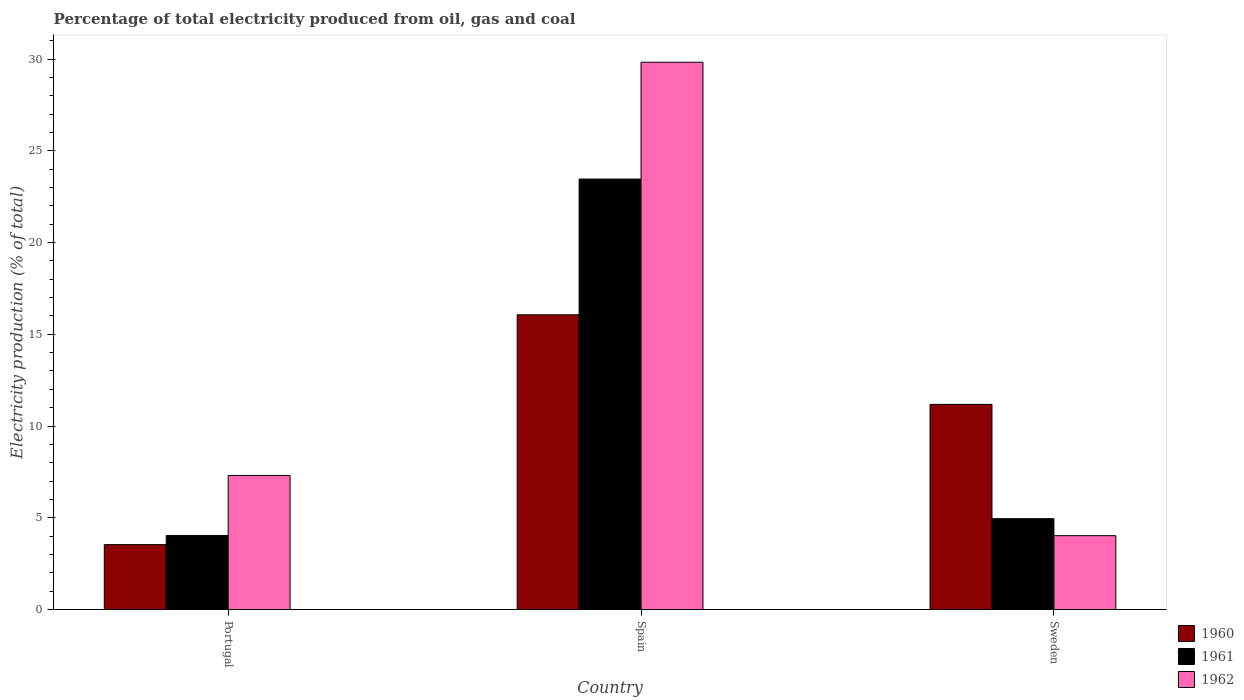How many groups of bars are there?
Make the answer very short. 3. Are the number of bars per tick equal to the number of legend labels?
Your answer should be very brief. Yes. How many bars are there on the 1st tick from the right?
Provide a succinct answer. 3. What is the label of the 1st group of bars from the left?
Give a very brief answer. Portugal. In how many cases, is the number of bars for a given country not equal to the number of legend labels?
Your answer should be compact. 0. What is the electricity production in in 1960 in Spain?
Keep it short and to the point. 16.06. Across all countries, what is the maximum electricity production in in 1962?
Give a very brief answer. 29.83. Across all countries, what is the minimum electricity production in in 1960?
Offer a very short reply. 3.54. What is the total electricity production in in 1961 in the graph?
Make the answer very short. 32.45. What is the difference between the electricity production in in 1960 in Spain and that in Sweden?
Keep it short and to the point. 4.88. What is the difference between the electricity production in in 1962 in Portugal and the electricity production in in 1961 in Sweden?
Your answer should be compact. 2.36. What is the average electricity production in in 1960 per country?
Make the answer very short. 10.26. What is the difference between the electricity production in of/in 1960 and electricity production in of/in 1961 in Spain?
Keep it short and to the point. -7.4. What is the ratio of the electricity production in in 1962 in Portugal to that in Sweden?
Your response must be concise. 1.82. Is the electricity production in in 1962 in Portugal less than that in Spain?
Give a very brief answer. Yes. What is the difference between the highest and the second highest electricity production in in 1960?
Your answer should be compact. 4.88. What is the difference between the highest and the lowest electricity production in in 1961?
Provide a short and direct response. 19.42. Is the sum of the electricity production in in 1961 in Portugal and Sweden greater than the maximum electricity production in in 1962 across all countries?
Give a very brief answer. No. Is it the case that in every country, the sum of the electricity production in in 1961 and electricity production in in 1962 is greater than the electricity production in in 1960?
Offer a terse response. No. Are all the bars in the graph horizontal?
Your response must be concise. No. Does the graph contain any zero values?
Ensure brevity in your answer.  No. Does the graph contain grids?
Make the answer very short. No. Where does the legend appear in the graph?
Ensure brevity in your answer.  Bottom right. How are the legend labels stacked?
Your response must be concise. Vertical. What is the title of the graph?
Your response must be concise. Percentage of total electricity produced from oil, gas and coal. What is the label or title of the Y-axis?
Your answer should be compact. Electricity production (% of total). What is the Electricity production (% of total) of 1960 in Portugal?
Offer a terse response. 3.54. What is the Electricity production (% of total) of 1961 in Portugal?
Your answer should be very brief. 4.04. What is the Electricity production (% of total) in 1962 in Portugal?
Your answer should be very brief. 7.31. What is the Electricity production (% of total) in 1960 in Spain?
Make the answer very short. 16.06. What is the Electricity production (% of total) of 1961 in Spain?
Your response must be concise. 23.46. What is the Electricity production (% of total) in 1962 in Spain?
Give a very brief answer. 29.83. What is the Electricity production (% of total) of 1960 in Sweden?
Keep it short and to the point. 11.18. What is the Electricity production (% of total) of 1961 in Sweden?
Provide a short and direct response. 4.95. What is the Electricity production (% of total) in 1962 in Sweden?
Make the answer very short. 4.02. Across all countries, what is the maximum Electricity production (% of total) in 1960?
Make the answer very short. 16.06. Across all countries, what is the maximum Electricity production (% of total) in 1961?
Ensure brevity in your answer.  23.46. Across all countries, what is the maximum Electricity production (% of total) of 1962?
Your response must be concise. 29.83. Across all countries, what is the minimum Electricity production (% of total) of 1960?
Provide a short and direct response. 3.54. Across all countries, what is the minimum Electricity production (% of total) in 1961?
Your response must be concise. 4.04. Across all countries, what is the minimum Electricity production (% of total) in 1962?
Your response must be concise. 4.02. What is the total Electricity production (% of total) of 1960 in the graph?
Keep it short and to the point. 30.78. What is the total Electricity production (% of total) of 1961 in the graph?
Ensure brevity in your answer.  32.45. What is the total Electricity production (% of total) of 1962 in the graph?
Give a very brief answer. 41.16. What is the difference between the Electricity production (% of total) of 1960 in Portugal and that in Spain?
Ensure brevity in your answer.  -12.53. What is the difference between the Electricity production (% of total) of 1961 in Portugal and that in Spain?
Provide a succinct answer. -19.42. What is the difference between the Electricity production (% of total) in 1962 in Portugal and that in Spain?
Your answer should be very brief. -22.52. What is the difference between the Electricity production (% of total) in 1960 in Portugal and that in Sweden?
Your answer should be very brief. -7.64. What is the difference between the Electricity production (% of total) in 1961 in Portugal and that in Sweden?
Provide a short and direct response. -0.92. What is the difference between the Electricity production (% of total) in 1962 in Portugal and that in Sweden?
Ensure brevity in your answer.  3.28. What is the difference between the Electricity production (% of total) in 1960 in Spain and that in Sweden?
Offer a very short reply. 4.88. What is the difference between the Electricity production (% of total) of 1961 in Spain and that in Sweden?
Your answer should be compact. 18.51. What is the difference between the Electricity production (% of total) in 1962 in Spain and that in Sweden?
Make the answer very short. 25.8. What is the difference between the Electricity production (% of total) in 1960 in Portugal and the Electricity production (% of total) in 1961 in Spain?
Give a very brief answer. -19.92. What is the difference between the Electricity production (% of total) in 1960 in Portugal and the Electricity production (% of total) in 1962 in Spain?
Offer a very short reply. -26.29. What is the difference between the Electricity production (% of total) in 1961 in Portugal and the Electricity production (% of total) in 1962 in Spain?
Make the answer very short. -25.79. What is the difference between the Electricity production (% of total) of 1960 in Portugal and the Electricity production (% of total) of 1961 in Sweden?
Provide a succinct answer. -1.41. What is the difference between the Electricity production (% of total) of 1960 in Portugal and the Electricity production (% of total) of 1962 in Sweden?
Offer a terse response. -0.49. What is the difference between the Electricity production (% of total) in 1961 in Portugal and the Electricity production (% of total) in 1962 in Sweden?
Give a very brief answer. 0.01. What is the difference between the Electricity production (% of total) of 1960 in Spain and the Electricity production (% of total) of 1961 in Sweden?
Your answer should be compact. 11.11. What is the difference between the Electricity production (% of total) of 1960 in Spain and the Electricity production (% of total) of 1962 in Sweden?
Your response must be concise. 12.04. What is the difference between the Electricity production (% of total) in 1961 in Spain and the Electricity production (% of total) in 1962 in Sweden?
Give a very brief answer. 19.44. What is the average Electricity production (% of total) in 1960 per country?
Your answer should be very brief. 10.26. What is the average Electricity production (% of total) in 1961 per country?
Offer a terse response. 10.82. What is the average Electricity production (% of total) of 1962 per country?
Provide a short and direct response. 13.72. What is the difference between the Electricity production (% of total) of 1960 and Electricity production (% of total) of 1961 in Portugal?
Your response must be concise. -0.5. What is the difference between the Electricity production (% of total) in 1960 and Electricity production (% of total) in 1962 in Portugal?
Your response must be concise. -3.77. What is the difference between the Electricity production (% of total) in 1961 and Electricity production (% of total) in 1962 in Portugal?
Make the answer very short. -3.27. What is the difference between the Electricity production (% of total) of 1960 and Electricity production (% of total) of 1961 in Spain?
Offer a terse response. -7.4. What is the difference between the Electricity production (% of total) of 1960 and Electricity production (% of total) of 1962 in Spain?
Offer a terse response. -13.76. What is the difference between the Electricity production (% of total) of 1961 and Electricity production (% of total) of 1962 in Spain?
Provide a short and direct response. -6.37. What is the difference between the Electricity production (% of total) of 1960 and Electricity production (% of total) of 1961 in Sweden?
Your answer should be very brief. 6.23. What is the difference between the Electricity production (% of total) in 1960 and Electricity production (% of total) in 1962 in Sweden?
Provide a succinct answer. 7.16. What is the difference between the Electricity production (% of total) of 1961 and Electricity production (% of total) of 1962 in Sweden?
Your answer should be very brief. 0.93. What is the ratio of the Electricity production (% of total) in 1960 in Portugal to that in Spain?
Make the answer very short. 0.22. What is the ratio of the Electricity production (% of total) in 1961 in Portugal to that in Spain?
Your answer should be compact. 0.17. What is the ratio of the Electricity production (% of total) in 1962 in Portugal to that in Spain?
Provide a short and direct response. 0.24. What is the ratio of the Electricity production (% of total) in 1960 in Portugal to that in Sweden?
Offer a very short reply. 0.32. What is the ratio of the Electricity production (% of total) of 1961 in Portugal to that in Sweden?
Make the answer very short. 0.82. What is the ratio of the Electricity production (% of total) of 1962 in Portugal to that in Sweden?
Your response must be concise. 1.82. What is the ratio of the Electricity production (% of total) of 1960 in Spain to that in Sweden?
Provide a succinct answer. 1.44. What is the ratio of the Electricity production (% of total) of 1961 in Spain to that in Sweden?
Offer a terse response. 4.74. What is the ratio of the Electricity production (% of total) in 1962 in Spain to that in Sweden?
Your answer should be compact. 7.41. What is the difference between the highest and the second highest Electricity production (% of total) in 1960?
Your response must be concise. 4.88. What is the difference between the highest and the second highest Electricity production (% of total) in 1961?
Ensure brevity in your answer.  18.51. What is the difference between the highest and the second highest Electricity production (% of total) of 1962?
Your response must be concise. 22.52. What is the difference between the highest and the lowest Electricity production (% of total) in 1960?
Your response must be concise. 12.53. What is the difference between the highest and the lowest Electricity production (% of total) in 1961?
Your answer should be very brief. 19.42. What is the difference between the highest and the lowest Electricity production (% of total) in 1962?
Provide a short and direct response. 25.8. 